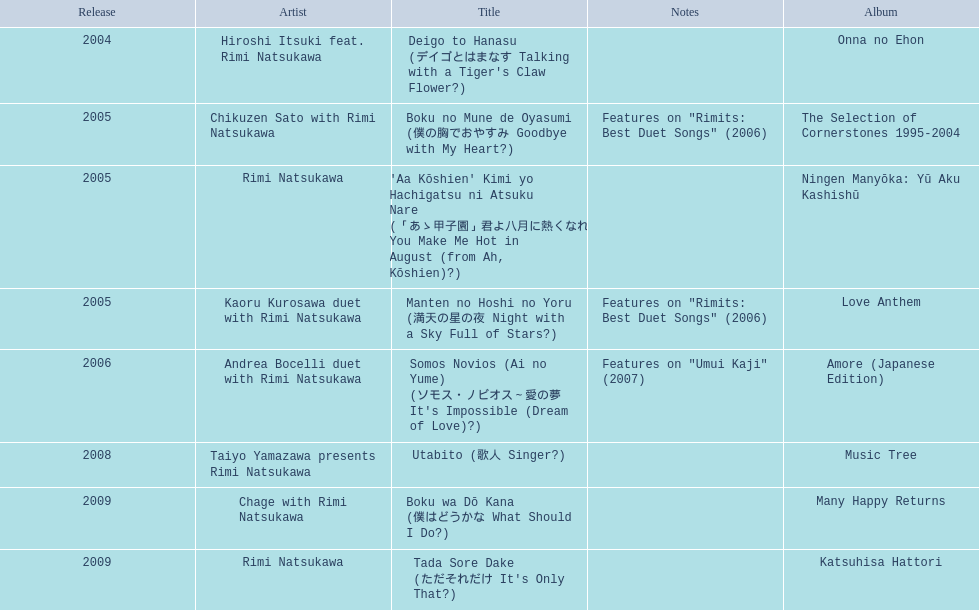In which year was "onna no ehon" released? 2004. In which year was "music tree" released? 2008. Which one of them was not released in 2004? Music Tree. 